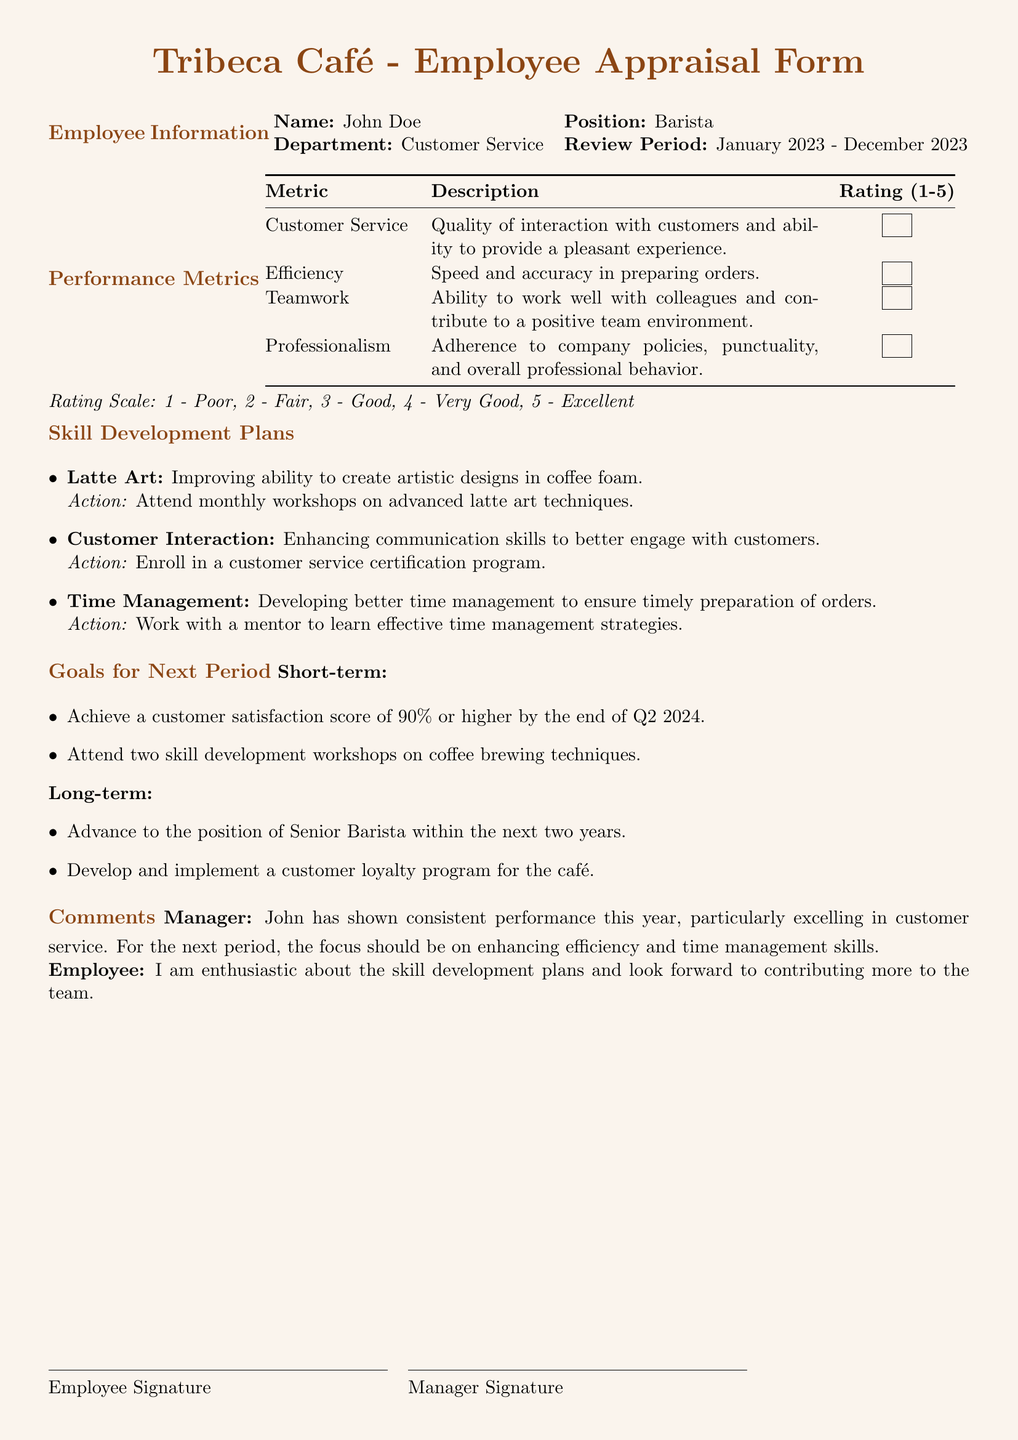What is the employee's name? The name is listed in the employee information section of the document.
Answer: John Doe What is the review period? The review period is specified directly in the employee information section.
Answer: January 2023 - December 2023 What is the rating scale used? The rating scale is mentioned at the end of the performance metrics section.
Answer: 1 - Poor, 2 - Fair, 3 - Good, 4 - Very Good, 5 - Excellent Which skill development plan involves workshops? This information can be found in the skill development plans section regarding latte art.
Answer: Latte Art What is the short-term goal for the customer satisfaction score? This goal is explicitly stated under the goals for the next period section.
Answer: 90% What is the employee's position? The position of the employee is mentioned in the employee information section.
Answer: Barista How many skill development workshops does the employee plan to attend in the short term? This is found in the short-term goals listed under goals for the next period.
Answer: Two What is the maximum rating possible for customer service? The maximum rating is specified in the performance metrics section where ratings are defined.
Answer: 5 What does the manager suggest as a focus area for the next period? This information is provided in the comments section from the manager.
Answer: Efficiency and time management skills 